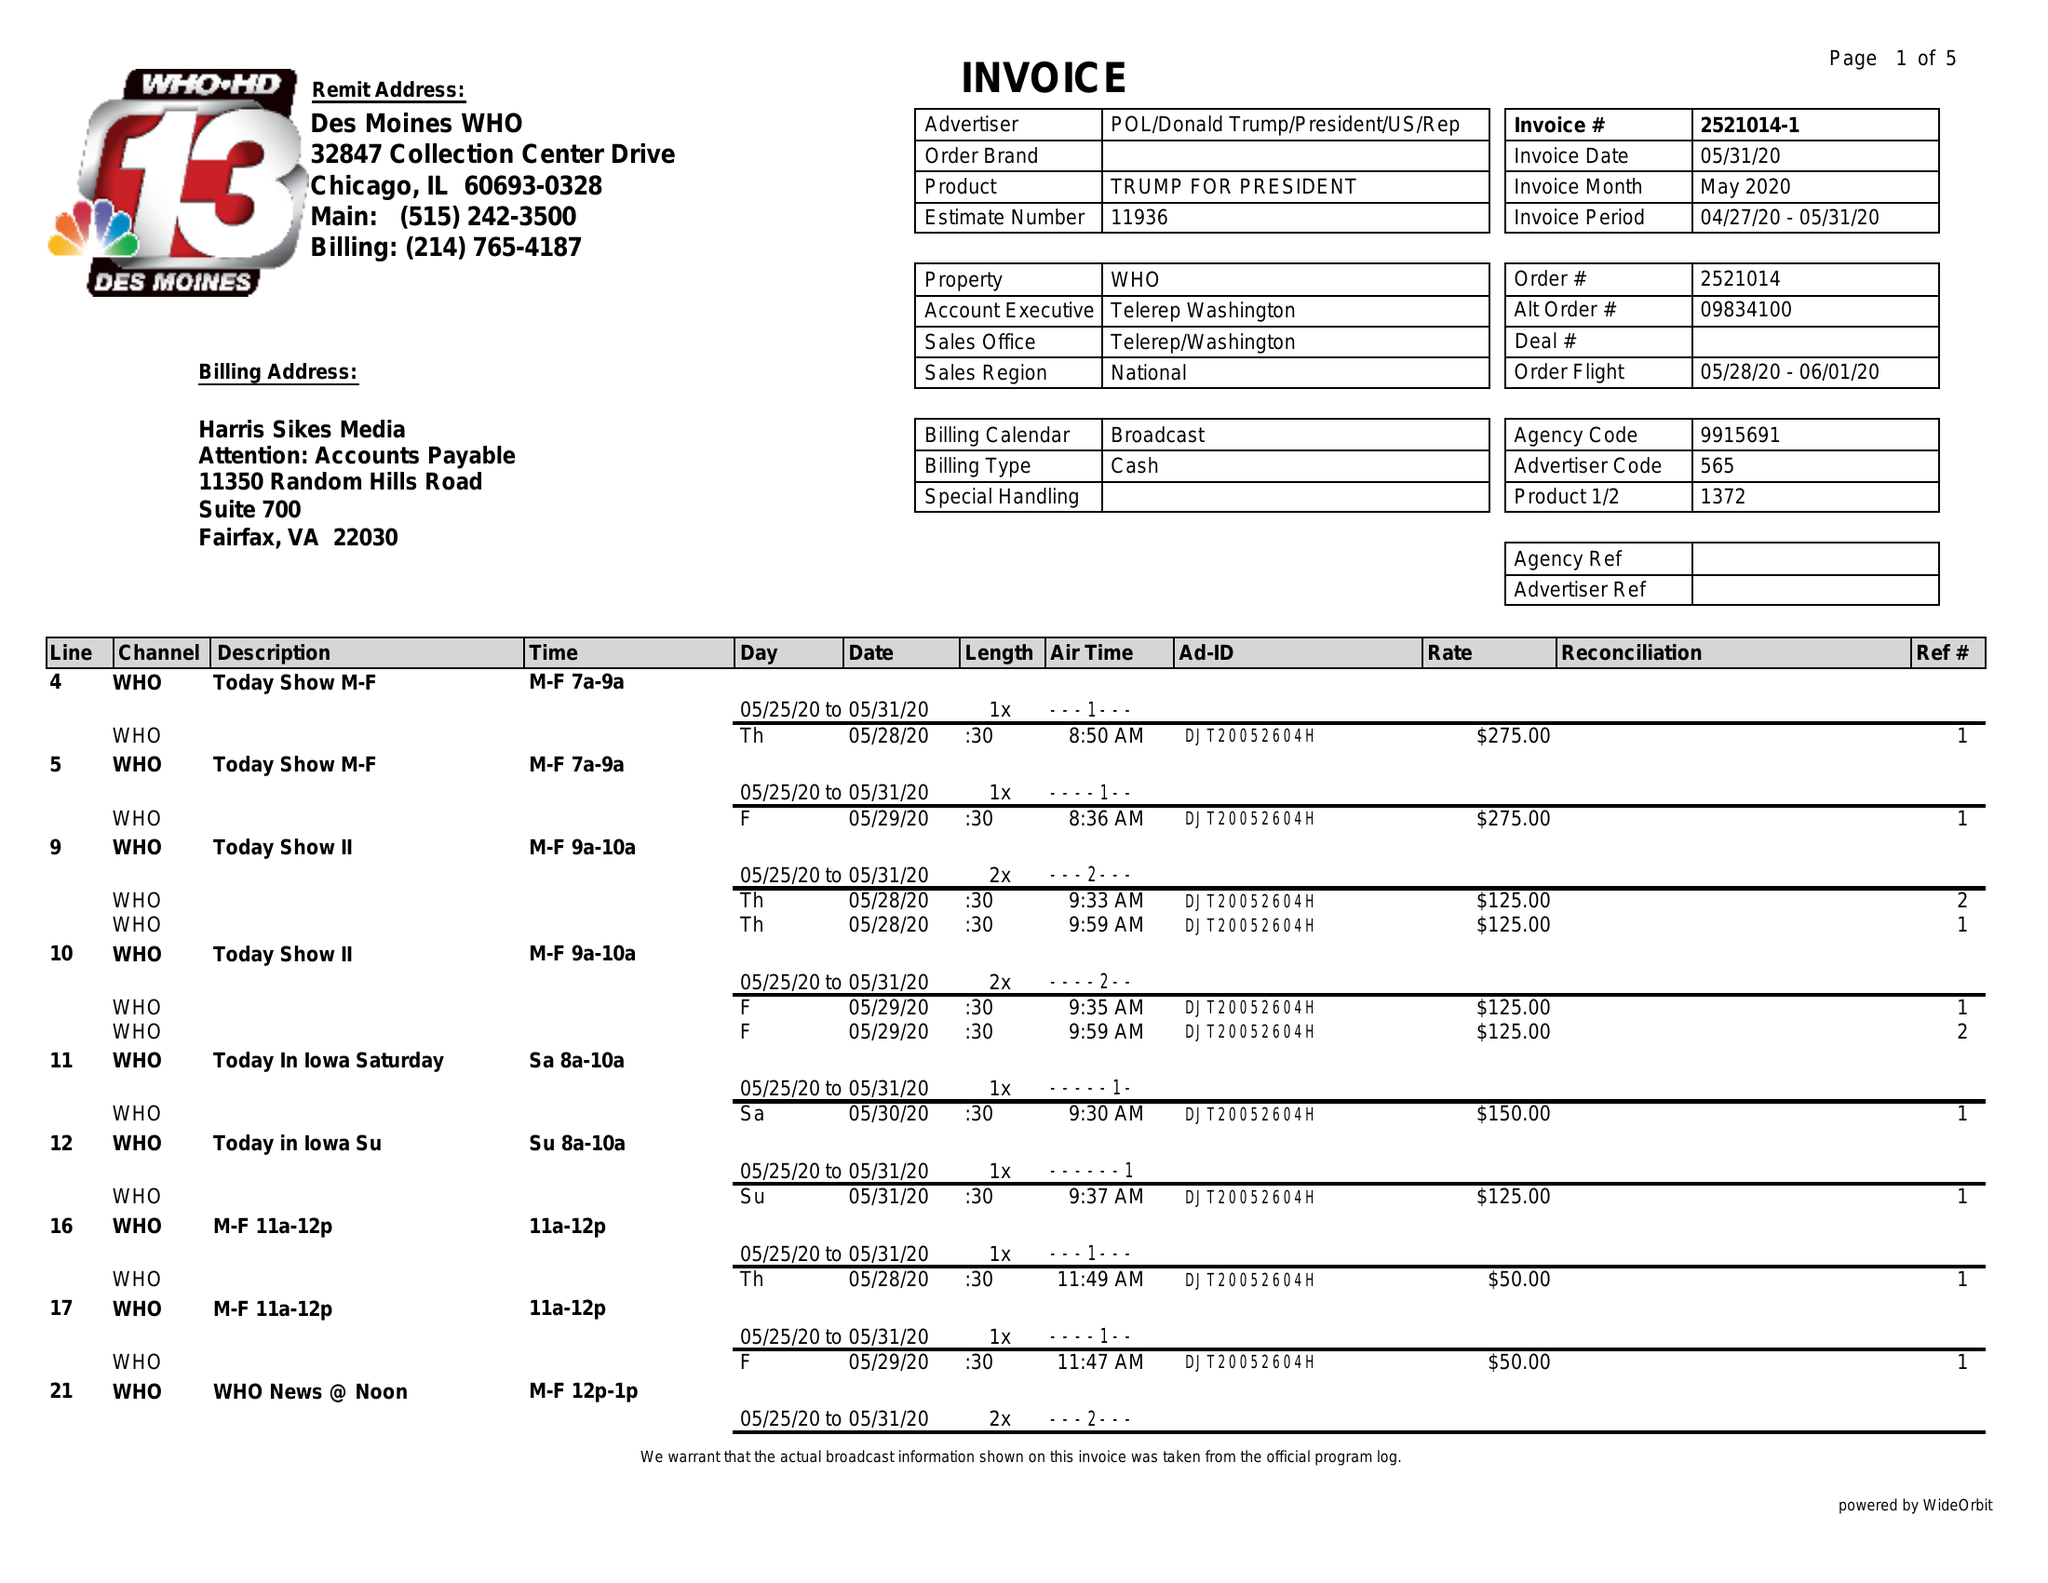What is the value for the flight_to?
Answer the question using a single word or phrase. 06/01/20 